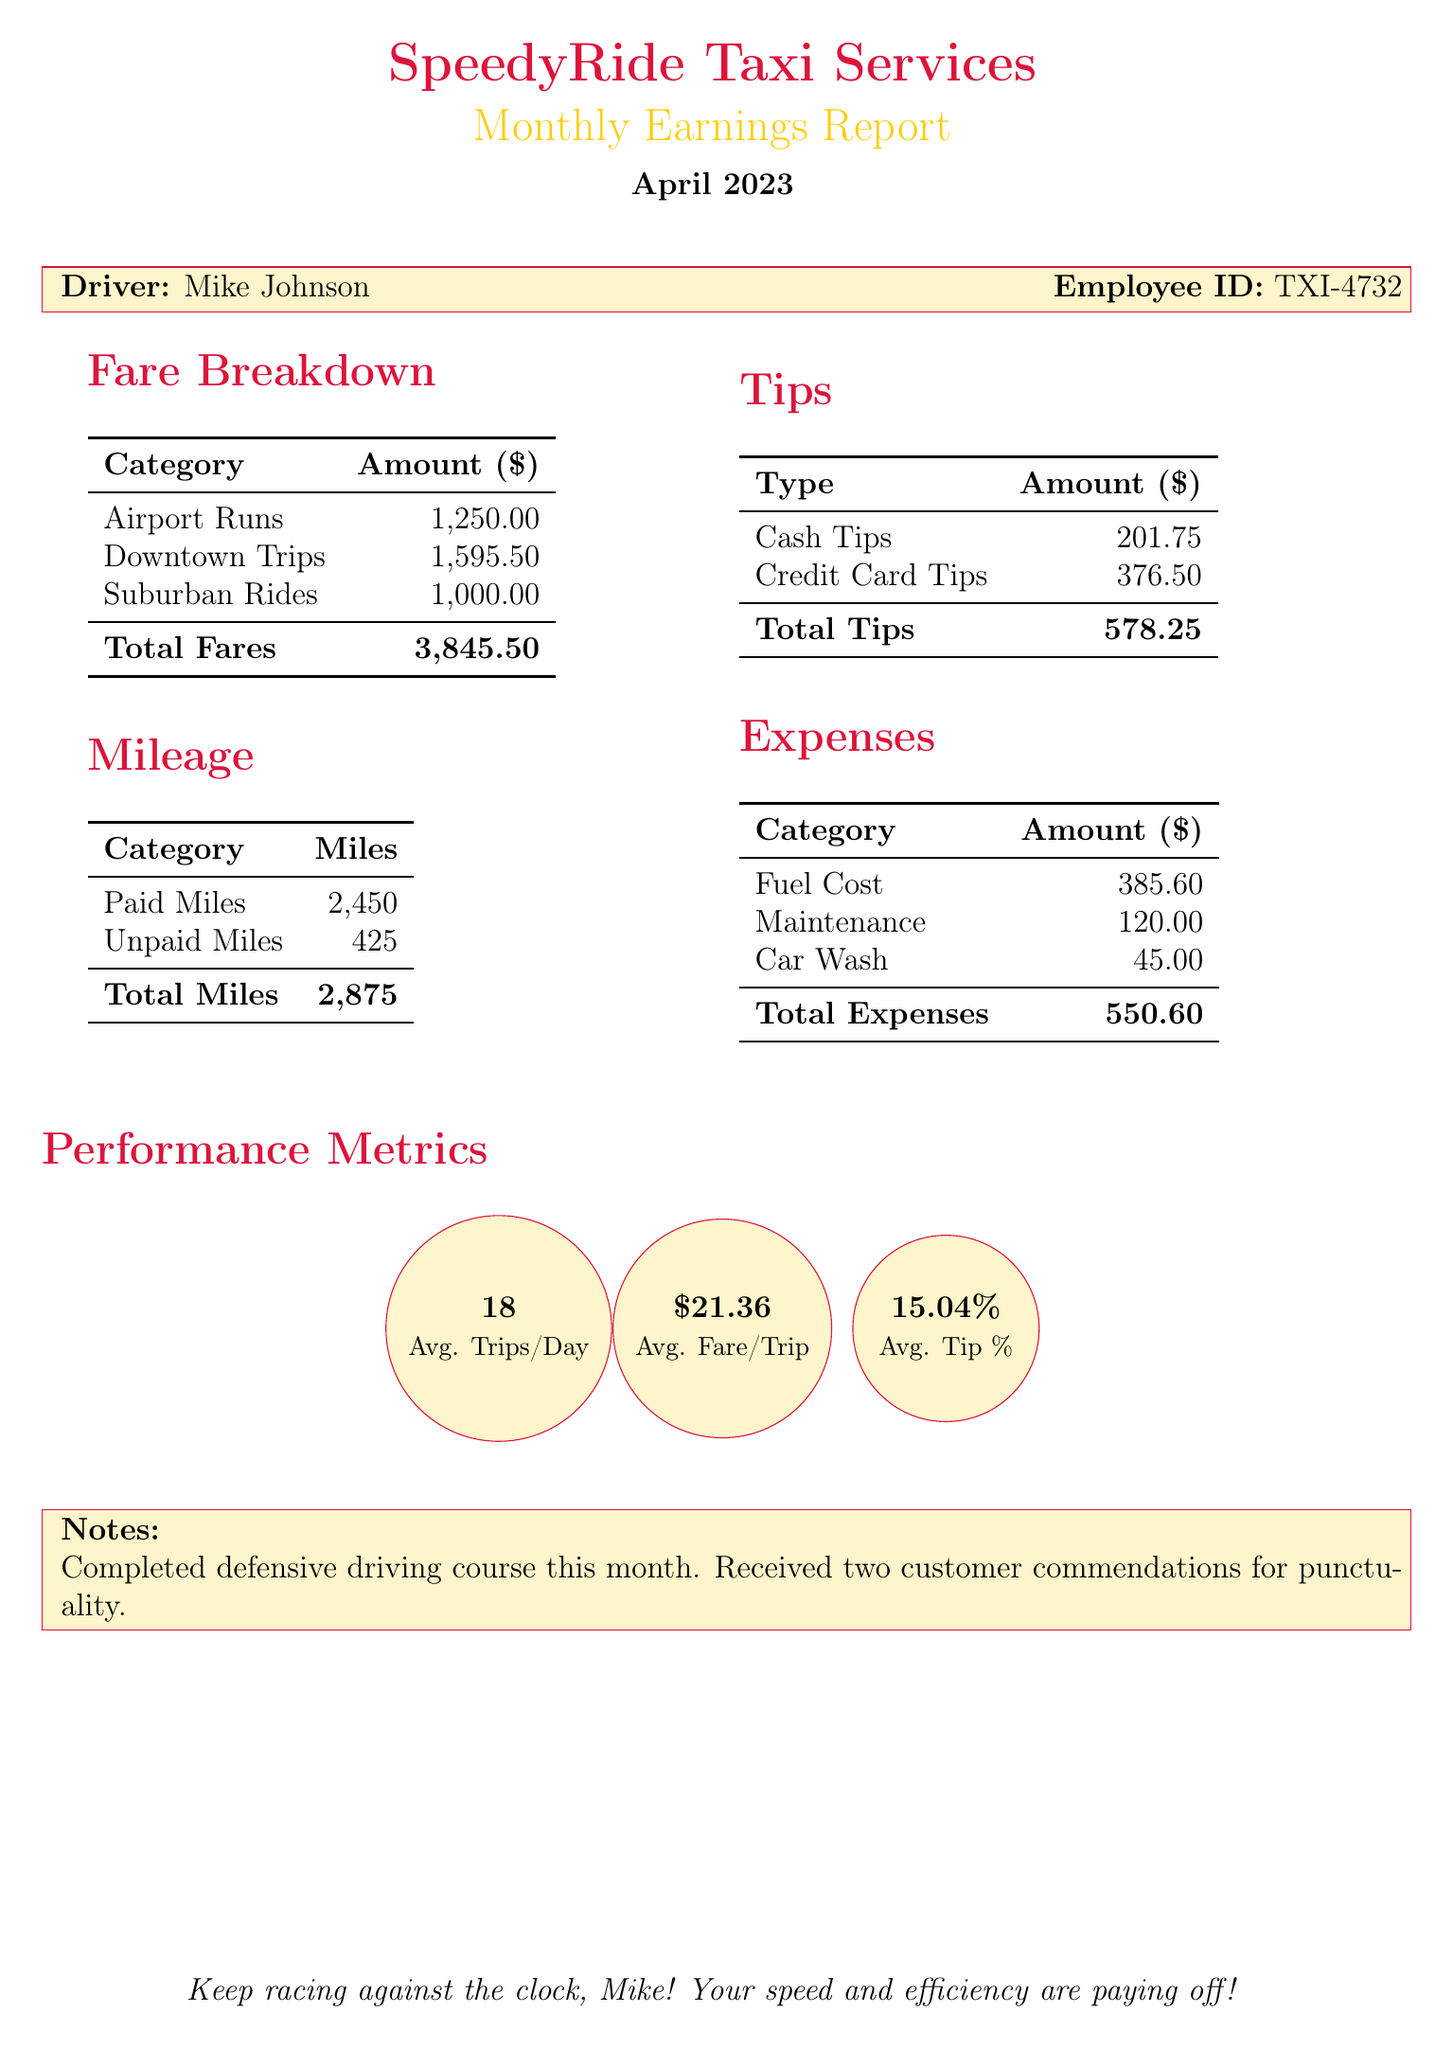what is the total fare collected? The total fare is listed under fare breakdown, which is $3845.50.
Answer: $3845.50 how many airport runs were completed? The amount related to airport runs is specified in the fare breakdown as $1250.00, which indicates multiple trips but the number is not directly stated.
Answer: Not specifically stated what is the total mileage driven? The total miles driven is detailed in the mileage section as 2875 miles.
Answer: 2875 what is the total amount received in tips? The total tips received is summarized in the tips section, which is $578.25.
Answer: $578.25 what is the average fare per trip? The average fare per trip is mentioned in the performance metrics section as $21.36.
Answer: $21.36 what is the total expense for fuel? The document specifies the fuel cost as $385.60 within the expenses section.
Answer: $385.60 how many trips are averaged per day? The average trips per day is detailed in the performance metrics as 18.
Answer: 18 how much were the cash tips received? Cash tips are stated in the tips section as $201.75.
Answer: $201.75 what was noted about customer feedback? The notes indicate that two customer commendations were received for punctuality.
Answer: Two commendations for punctuality 